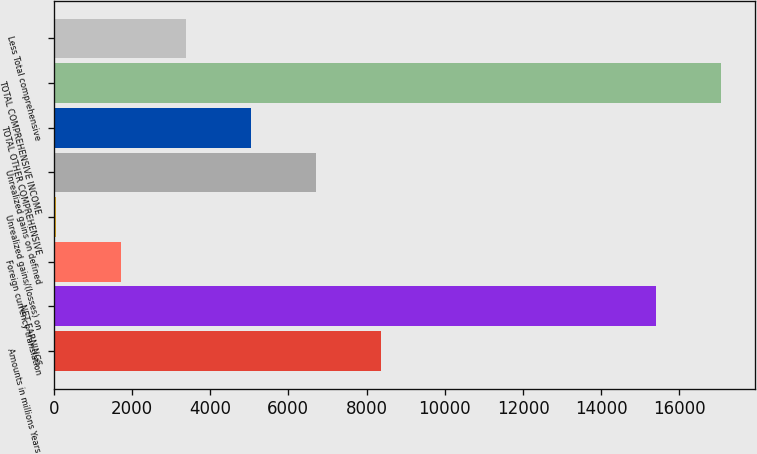Convert chart to OTSL. <chart><loc_0><loc_0><loc_500><loc_500><bar_chart><fcel>Amounts in millions Years<fcel>NET EARNINGS<fcel>Foreign currency translation<fcel>Unrealized gains/(losses) on<fcel>Unrealized gains on defined<fcel>TOTAL OTHER COMPREHENSIVE<fcel>TOTAL COMPREHENSIVE INCOME<fcel>Less Total comprehensive<nl><fcel>8372.5<fcel>15411<fcel>1721.7<fcel>59<fcel>6709.8<fcel>5047.1<fcel>17073.7<fcel>3384.4<nl></chart> 